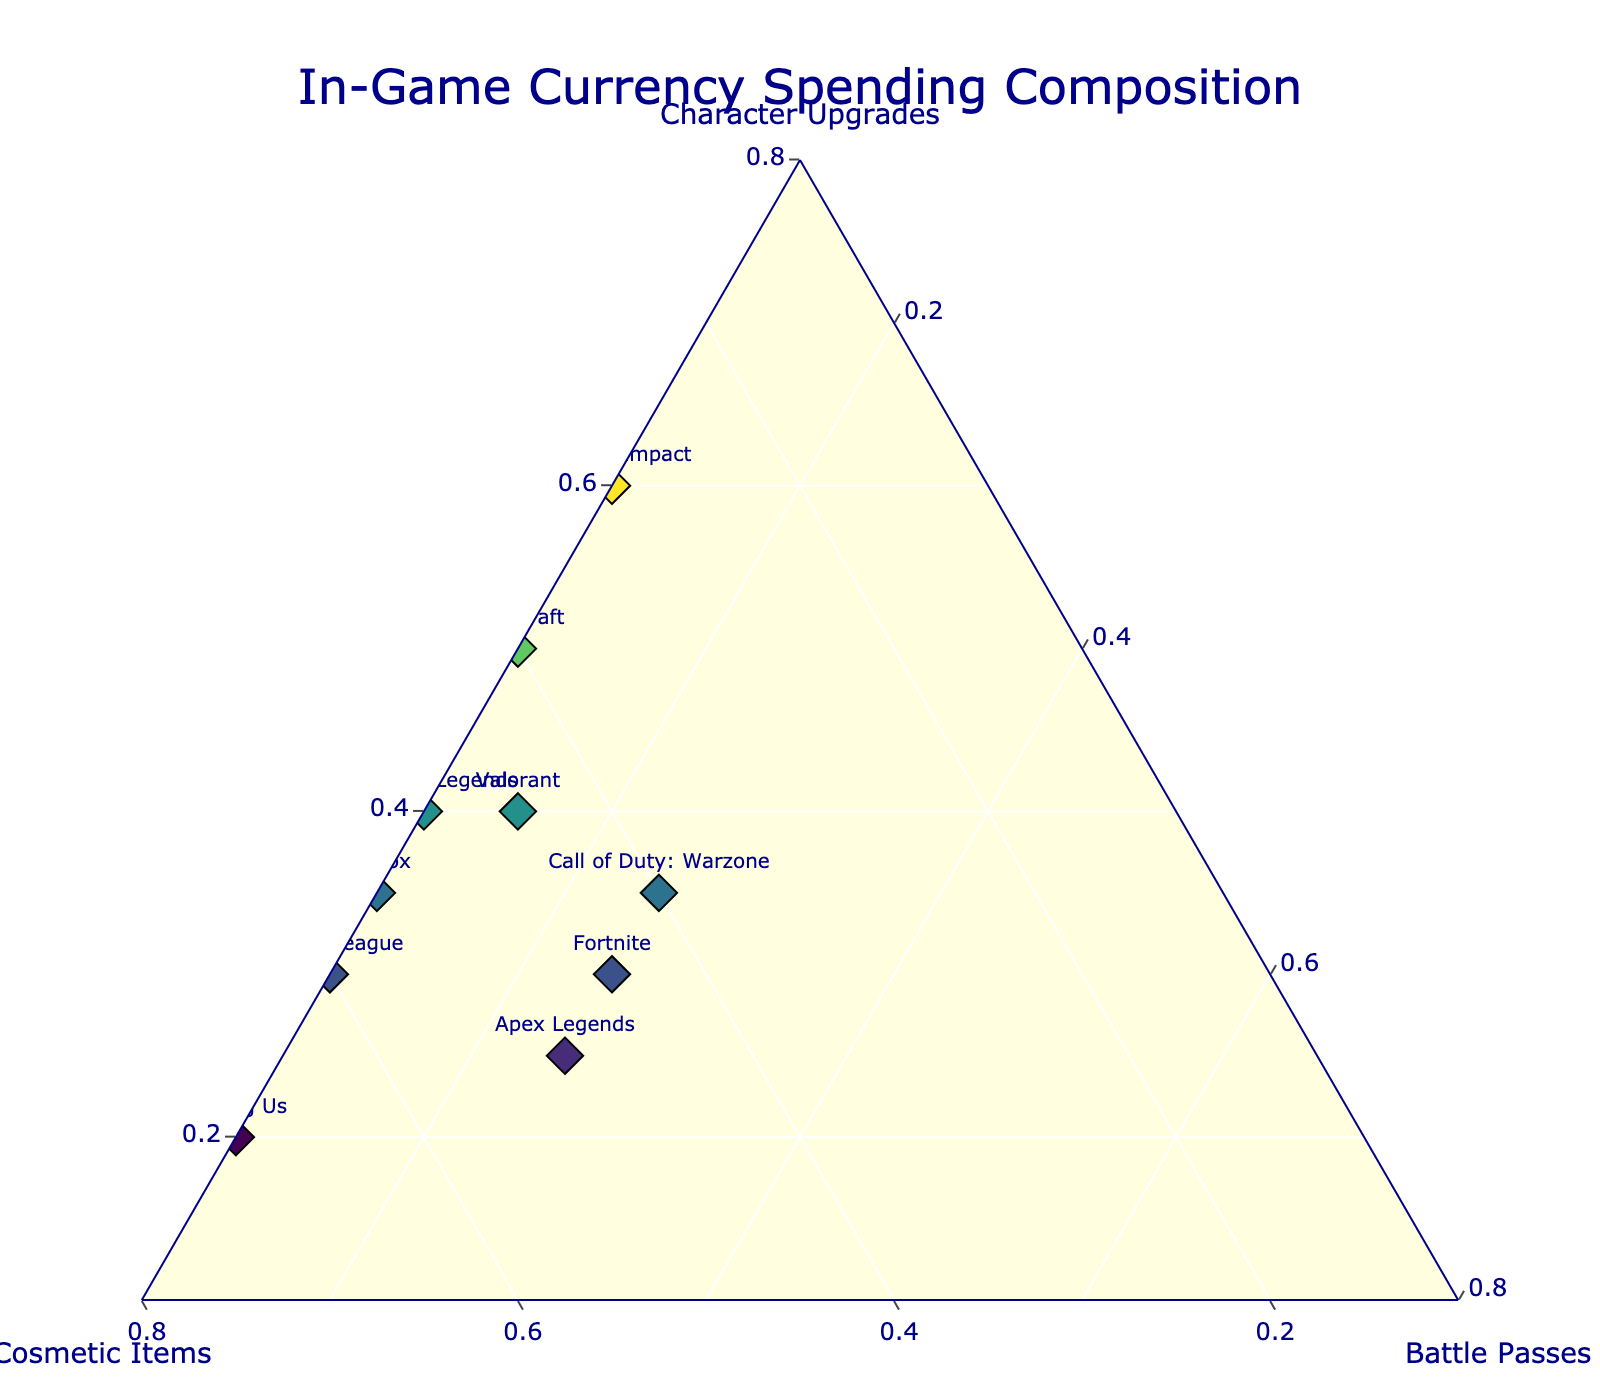What's the title of the figure? The title is placed prominently at the top of the figure. By observing this area, you can read the exact wording.
Answer: In-Game Currency Spending Composition How many games are represented in the plot? Each game is represented by a labeled data point. Counting these labels will reveal the number of games.
Answer: 10 Which axis represents spending on Character Upgrades? There are three axes for the types of spending. The axis labeled "Character Upgrades" represents this category.
Answer: A-axis Which game has the highest spending on Character Upgrades? The game furthest towards the "Character Upgrades" axis tip shows the highest spending in that category.
Answer: Genshin Impact How much does Apex Legends spend on Cosmetic Items? Locate the "Apex Legends" data point and look at its position relative to the "Cosmetic Items" axis to determine the spending.
Answer: 50 Which game spends equally on Character Upgrades and Battle Passes? Look for data points that are equidistant from the "Character Upgrades" and "Battle Passes" axes.
Answer: Fortnite Compare the spending on Character Upgrades between Minecraft and Call of Duty: Warzone. Which game spends more? Identify the data points for Minecraft and Call of Duty: Warzone and check their positions relative to the "Character Upgrades" axis.
Answer: Minecraft Which game has the most balanced spending across all three categories? The most balanced spending would be closer to the center of the triangle. Identify the point nearest the center without major leaning towards any axes.
Answer: Apex Legends Among Us focuses heavily on which type of spending? Check the apex closest to the "Among Us" data point to determine which spending category it is nearest.
Answer: Cosmetic Items How does the spending distribution on Cosmetic Items for Roblox compare to Rocket League? Look at the relative positions of Roblox and Rocket League concerning the "Cosmetic Items" axis and compare their distances.
Answer: Roblox spends more 